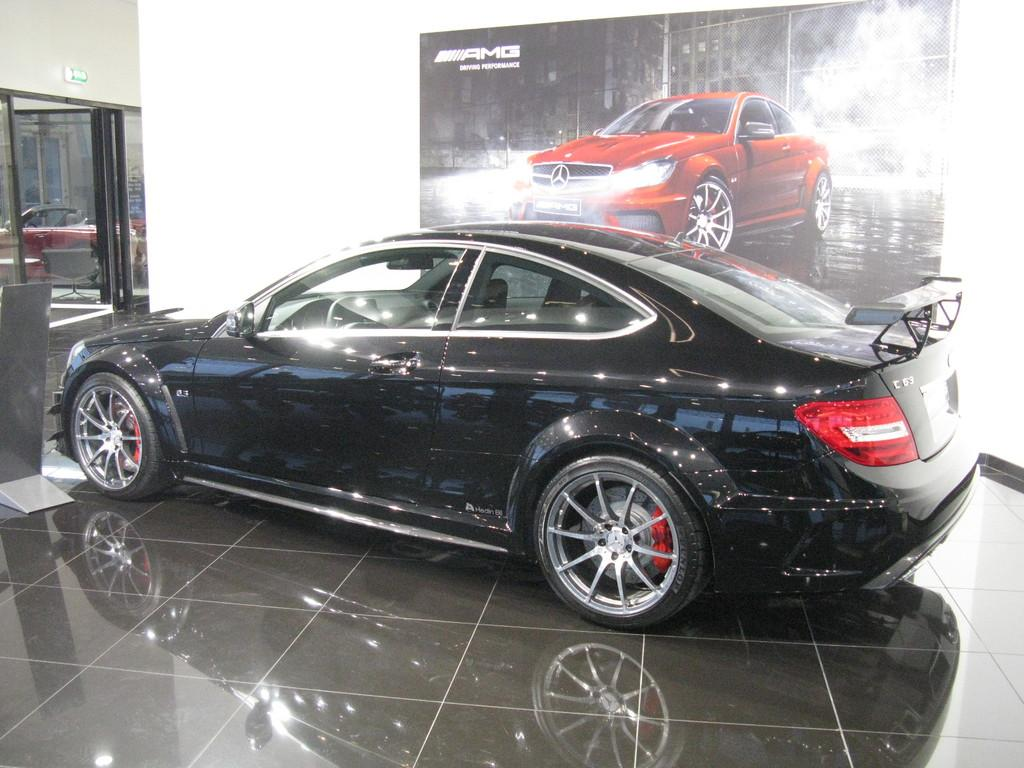What object is placed on the floor in the image? There is a car on the floor in the image. Can you describe any other features in the image? There is a door visible in the image. What else related to a car can be seen in the image? There is a posture of a car on the wall in the image. What type of haircut does the beggar have in the image? There is no beggar or haircut present in the image. What kind of work is being done by the people in the image? There are no people or work-related activities depicted in the image. 